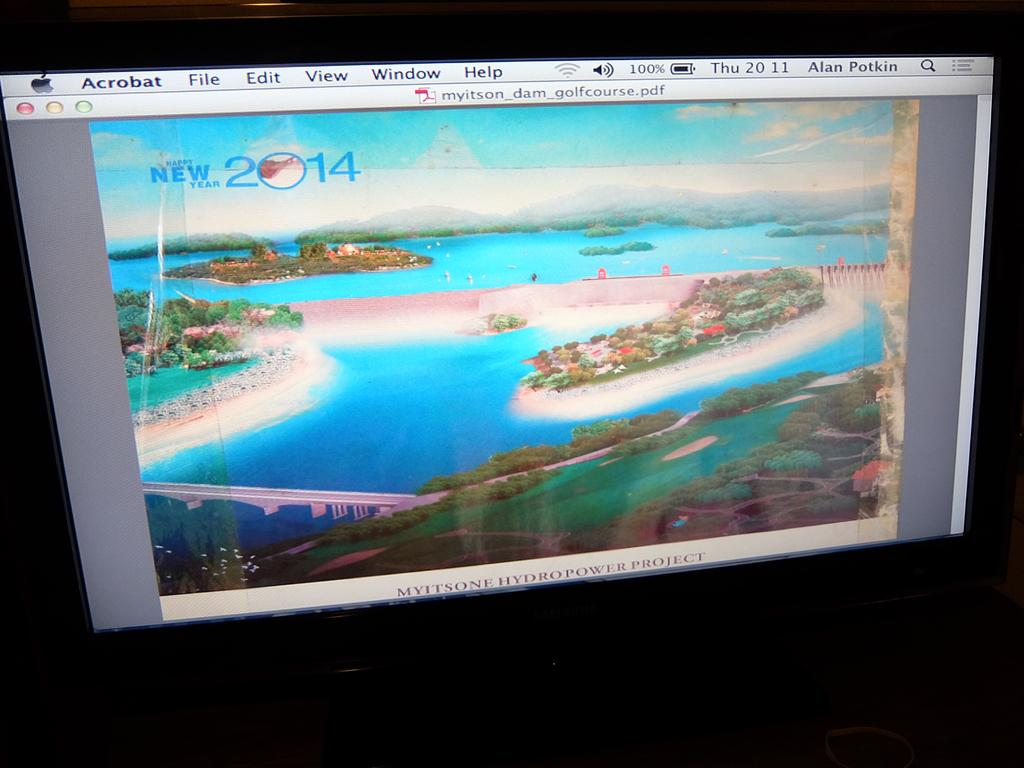Provide a one-sentence caption for the provided image. acrobat is a program with a nice image on it. 